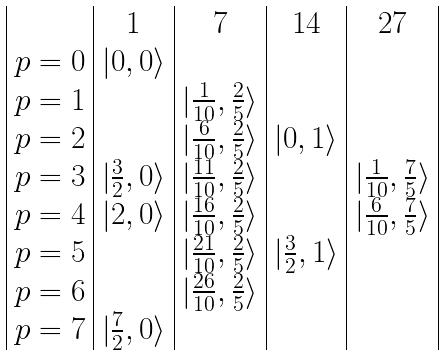Convert formula to latex. <formula><loc_0><loc_0><loc_500><loc_500>\begin{array} { | c | c | c | c | c | } & { 1 } & { 7 } & { 1 4 } & { 2 7 } \\ p = 0 & | 0 , 0 \rangle & & & \\ p = 1 & & | \frac { 1 } { 1 0 } , \frac { 2 } { 5 } \rangle & & \\ p = 2 & & | \frac { 6 } { 1 0 } , \frac { 2 } { 5 } \rangle & | 0 , 1 \rangle & \\ p = 3 & | \frac { 3 } { 2 } , 0 \rangle & | \frac { 1 1 } { 1 0 } , \frac { 2 } { 5 } \rangle & & | \frac { 1 } { 1 0 } , \frac { 7 } { 5 } \rangle \\ p = 4 & | 2 , 0 \rangle & | \frac { 1 6 } { 1 0 } , \frac { 2 } { 5 } \rangle & & | \frac { 6 } { 1 0 } , \frac { 7 } { 5 } \rangle \\ p = 5 & & | \frac { 2 1 } { 1 0 } , \frac { 2 } { 5 } \rangle & | \frac { 3 } { 2 } , 1 \rangle & \\ p = 6 & & | \frac { 2 6 } { 1 0 } , \frac { 2 } { 5 } \rangle & & \\ p = 7 & | \frac { 7 } { 2 } , 0 \rangle & & & \\ \end{array}</formula> 